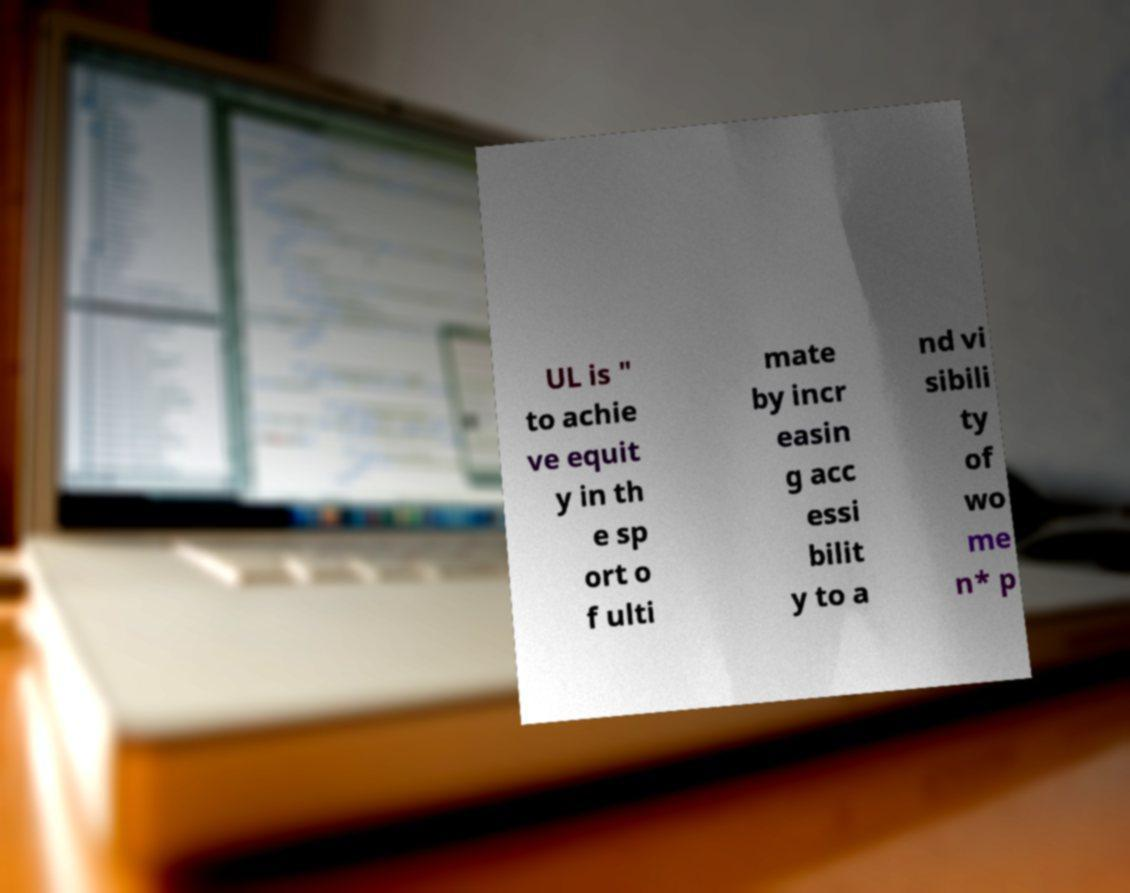What messages or text are displayed in this image? I need them in a readable, typed format. UL is " to achie ve equit y in th e sp ort o f ulti mate by incr easin g acc essi bilit y to a nd vi sibili ty of wo me n* p 